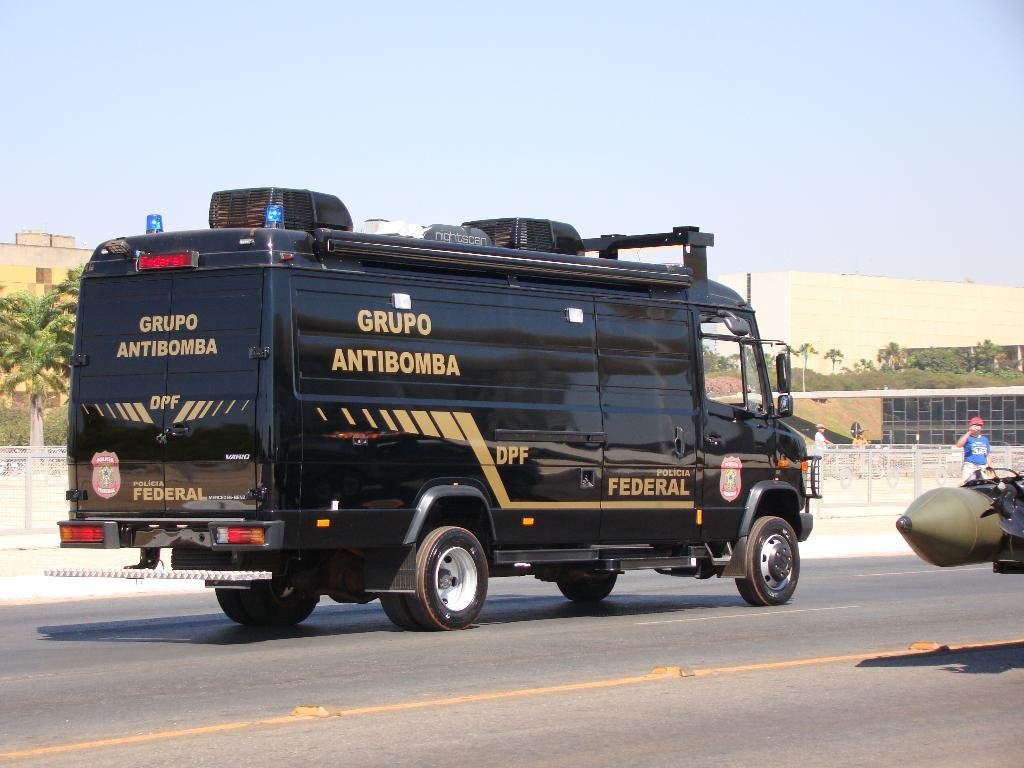Provide a one-sentence caption for the provided image. A black car from the government is driving down the street. 